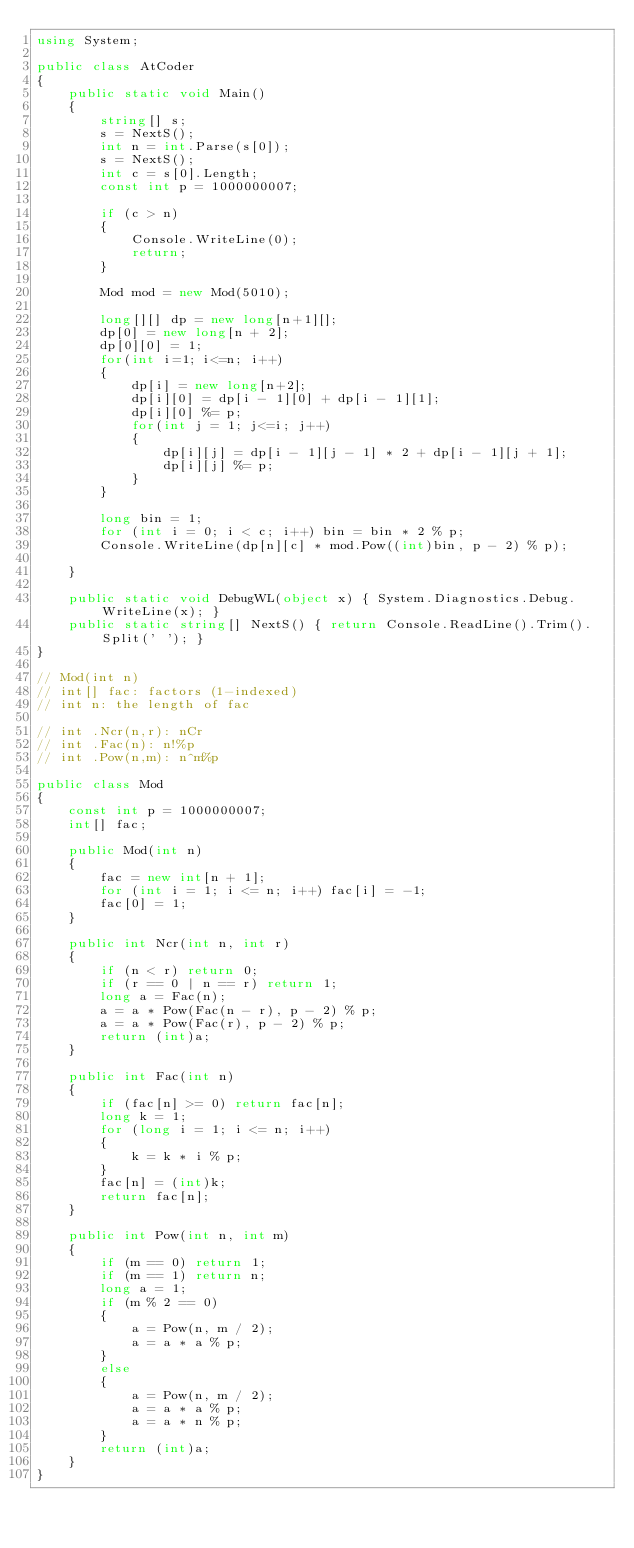Convert code to text. <code><loc_0><loc_0><loc_500><loc_500><_C#_>using System;

public class AtCoder
{
    public static void Main()
    {
        string[] s;
        s = NextS();
        int n = int.Parse(s[0]);
        s = NextS();
        int c = s[0].Length;
        const int p = 1000000007;

        if (c > n)
        {
            Console.WriteLine(0);
            return;
        }

        Mod mod = new Mod(5010);

        long[][] dp = new long[n+1][];
        dp[0] = new long[n + 2];
        dp[0][0] = 1;
        for(int i=1; i<=n; i++)
        {
            dp[i] = new long[n+2];
            dp[i][0] = dp[i - 1][0] + dp[i - 1][1];
            dp[i][0] %= p;
            for(int j = 1; j<=i; j++)
            {
                dp[i][j] = dp[i - 1][j - 1] * 2 + dp[i - 1][j + 1];
                dp[i][j] %= p;
            }         
        }

        long bin = 1;
        for (int i = 0; i < c; i++) bin = bin * 2 % p;
        Console.WriteLine(dp[n][c] * mod.Pow((int)bin, p - 2) % p);

    }

    public static void DebugWL(object x) { System.Diagnostics.Debug.WriteLine(x); }
    public static string[] NextS() { return Console.ReadLine().Trim().Split(' '); }
}

// Mod(int n)
// int[] fac: factors (1-indexed)
// int n: the length of fac

// int .Ncr(n,r): nCr
// int .Fac(n): n!%p
// int .Pow(n,m): n^m%p

public class Mod
{
    const int p = 1000000007;
    int[] fac;

    public Mod(int n)
    {
        fac = new int[n + 1];
        for (int i = 1; i <= n; i++) fac[i] = -1;
        fac[0] = 1;
    }

    public int Ncr(int n, int r)
    {
        if (n < r) return 0;
        if (r == 0 | n == r) return 1;
        long a = Fac(n);
        a = a * Pow(Fac(n - r), p - 2) % p;
        a = a * Pow(Fac(r), p - 2) % p;
        return (int)a;
    }

    public int Fac(int n)
    {
        if (fac[n] >= 0) return fac[n];
        long k = 1;
        for (long i = 1; i <= n; i++)
        {
            k = k * i % p;
        }
        fac[n] = (int)k;
        return fac[n];
    }

    public int Pow(int n, int m)
    {
        if (m == 0) return 1;
        if (m == 1) return n;
        long a = 1;
        if (m % 2 == 0)
        {
            a = Pow(n, m / 2);
            a = a * a % p;
        }
        else
        {
            a = Pow(n, m / 2);
            a = a * a % p;
            a = a * n % p;
        }
        return (int)a;
    }
}</code> 